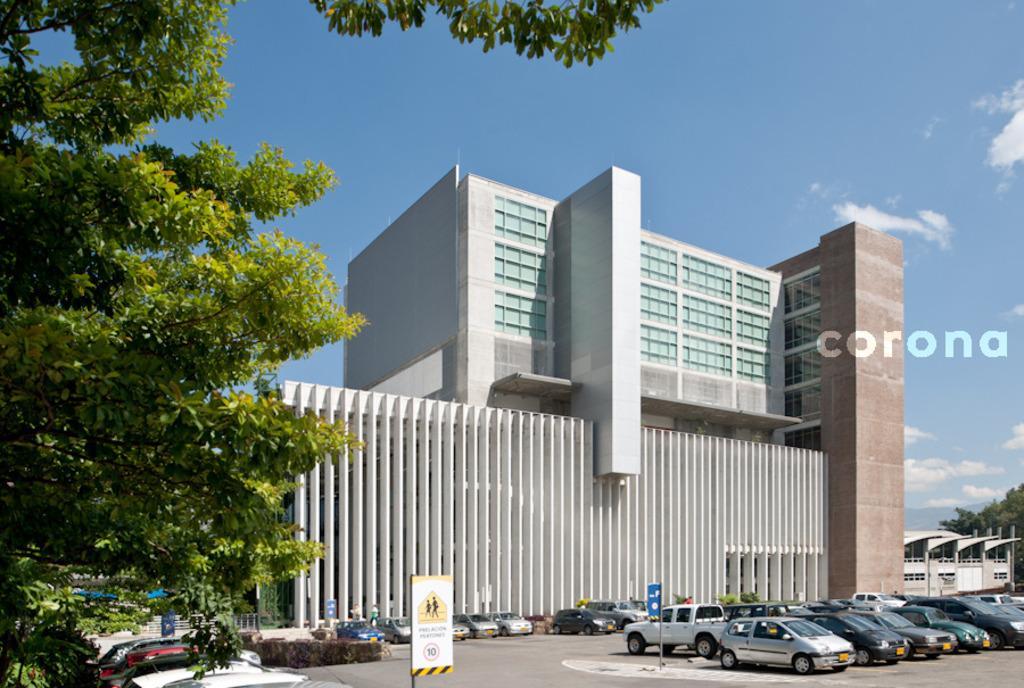Please provide a concise description of this image. In this image we can see a building. In front of the building we can see a group of vehicles and plants. On both sides of the image we can see few trees. At the top we can see the sky. 